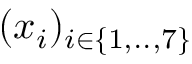Convert formula to latex. <formula><loc_0><loc_0><loc_500><loc_500>( x _ { i } ) _ { i \in \{ 1 , . . , 7 \} }</formula> 